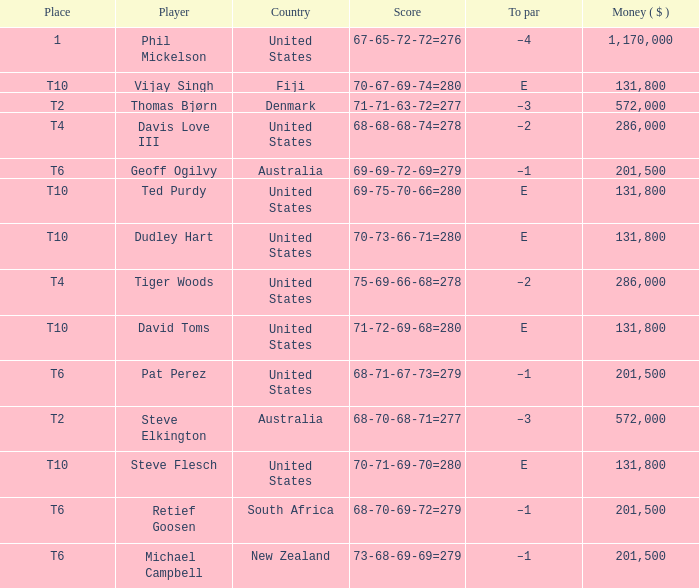What is the largest money for a t4 place, for Tiger Woods? 286000.0. 